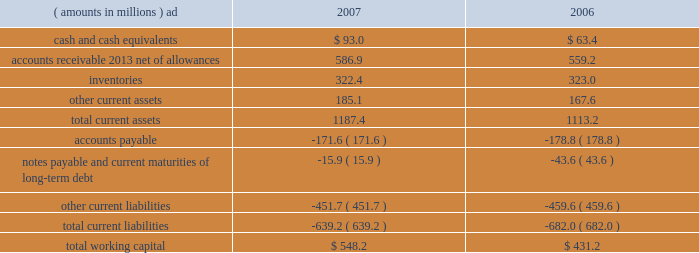2007 annual report 39 corporate snap-on 2019s general corporate expenses totaled $ 53.8 million in 2006 , up from $ 46.4 million in 2005 , primarily due to $ 15.2 million of increased stock-based and performance-based incentive compensation , including $ 6.3 million from the january 1 , 2006 , adoption of sfas no .
123 ( r ) .
Increased expenses in 2006 also included $ 4.2 million of higher insurance and other costs .
These expense increases were partially offset by $ 9.5 million of benefits from rci initiatives .
See note 13 to the consolidated financial statements for information on the company 2019s adoption of sfas no .
123 ( r ) .
Financial condition snap-on 2019s growth has historically been funded by a combination of cash provided by operating activities and debt financing .
Snap-on believes that its cash from operations , coupled with its sources of borrowings , are sufficient to fund its anticipated requirements for working capital , capital expenditures , restructuring activities , acquisitions , common stock repurchases and dividend payments .
Due to snap-on 2019s credit rating over the years , external funds have been available at a reasonable cost .
As of the close of business on february 15 , 2008 , snap-on 2019s long-term debt and commercial paper was rated a3 and p-2 by moody 2019s investors service and a- and a-2 by standard & poor 2019s .
Snap-on believes that the strength of its balance sheet , combined with its cash flows from operating activities , affords the company the financial flexibility to respond to both internal growth opportunities and those available through acquisitions .
The following discussion focuses on information included in the accompanying consolidated balance sheets .
Snap-on has been focused on improving asset utilization by making more effective use of its investment in certain working capital items .
The company assesses management 2019s operating performance and effectiveness relative to those components of working capital , particularly accounts receivable and inventories , that are more directly impacted by operational decisions .
As of december 29 , 2007 , working capital ( current assets less current liabilities ) of $ 548.2 million was up $ 117.0 million from $ 431.2 million as of december 30 , 2006 .
The increase in year-over-year working capital primarily reflects higher levels of 201ccash and cash equivalents 201d of $ 29.6 million , lower 201cnotes payable and current maturities of long-term debt 201d of $ 27.7 million , and $ 27.7 million of increased 201caccounts receivable 2013 net of allowances . 201d the following represents the company 2019s working capital position as of december 29 , 2007 , and december 30 , 2006 .
( amounts in millions ) 2007 2006 .
Accounts receivable at the end of 2007 was $ 586.9 million , up $ 27.7 million from year-end 2006 levels .
The year-over- year increase in accounts receivable primarily reflects the impact of higher sales in the fourth quarter of 2007 and $ 25.1 million of currency translation .
This increase in accounts receivable was partially offset by lower levels of receivables as a result of an improvement in days sales outstanding from 76 days at year-end 2006 to 73 days at year-end 2007. .
What is the percentage change in total current assets from 2006 to 2007? 
Computations: ((1187.4 - 1113.2) / 1113.2)
Answer: 0.06665. 